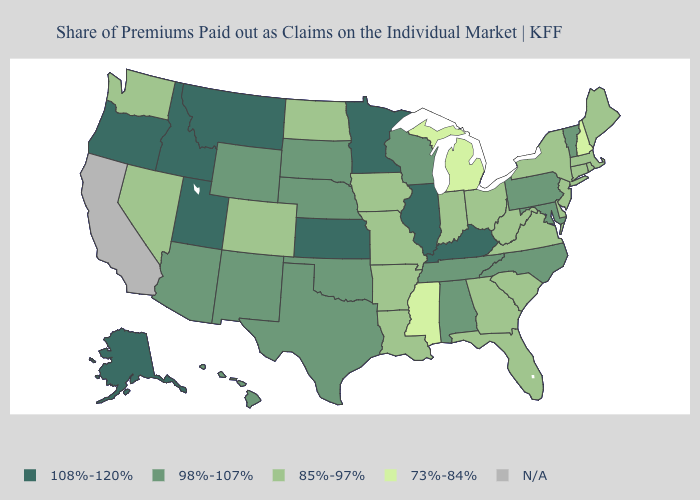Does Georgia have the highest value in the South?
Be succinct. No. Among the states that border New Jersey , does Delaware have the highest value?
Answer briefly. No. How many symbols are there in the legend?
Answer briefly. 5. What is the value of Alaska?
Give a very brief answer. 108%-120%. Which states have the highest value in the USA?
Give a very brief answer. Alaska, Idaho, Illinois, Kansas, Kentucky, Minnesota, Montana, Oregon, Utah. What is the value of West Virginia?
Write a very short answer. 85%-97%. What is the lowest value in the West?
Be succinct. 85%-97%. What is the lowest value in the MidWest?
Be succinct. 73%-84%. Which states have the lowest value in the USA?
Short answer required. Michigan, Mississippi, New Hampshire. What is the value of Georgia?
Short answer required. 85%-97%. What is the highest value in the USA?
Answer briefly. 108%-120%. What is the lowest value in the USA?
Be succinct. 73%-84%. Among the states that border Virginia , does Kentucky have the highest value?
Concise answer only. Yes. Does New Hampshire have the lowest value in the Northeast?
Concise answer only. Yes. What is the highest value in the Northeast ?
Keep it brief. 98%-107%. 